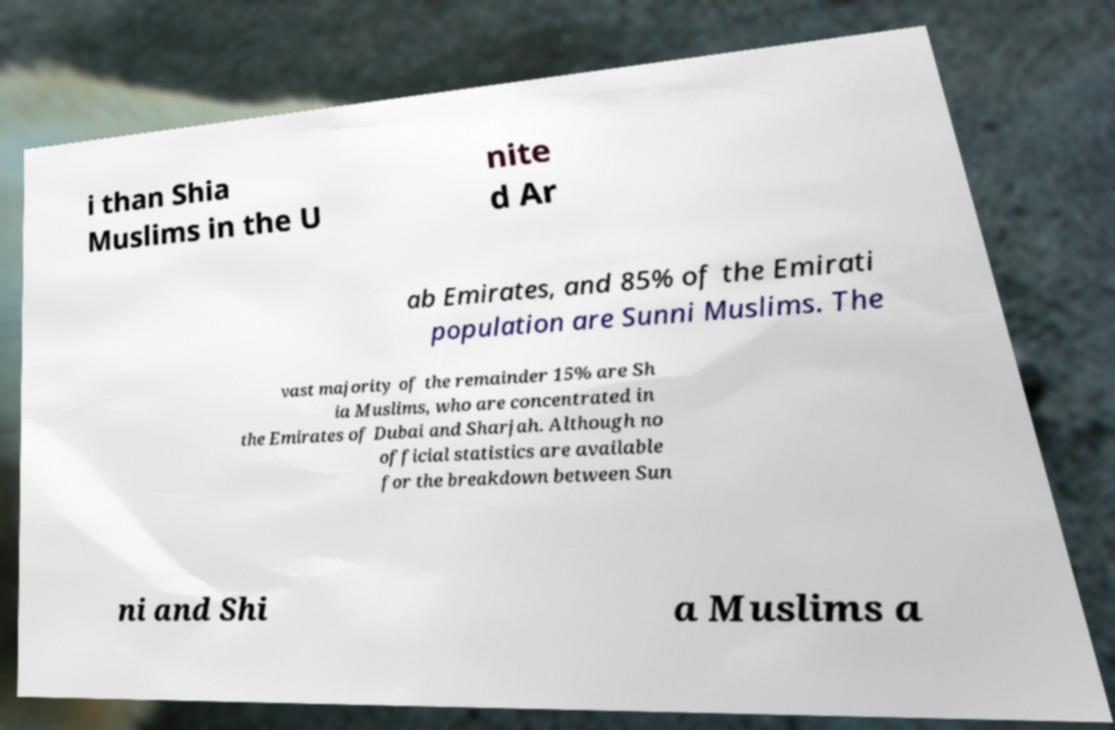Could you assist in decoding the text presented in this image and type it out clearly? i than Shia Muslims in the U nite d Ar ab Emirates, and 85% of the Emirati population are Sunni Muslims. The vast majority of the remainder 15% are Sh ia Muslims, who are concentrated in the Emirates of Dubai and Sharjah. Although no official statistics are available for the breakdown between Sun ni and Shi a Muslims a 